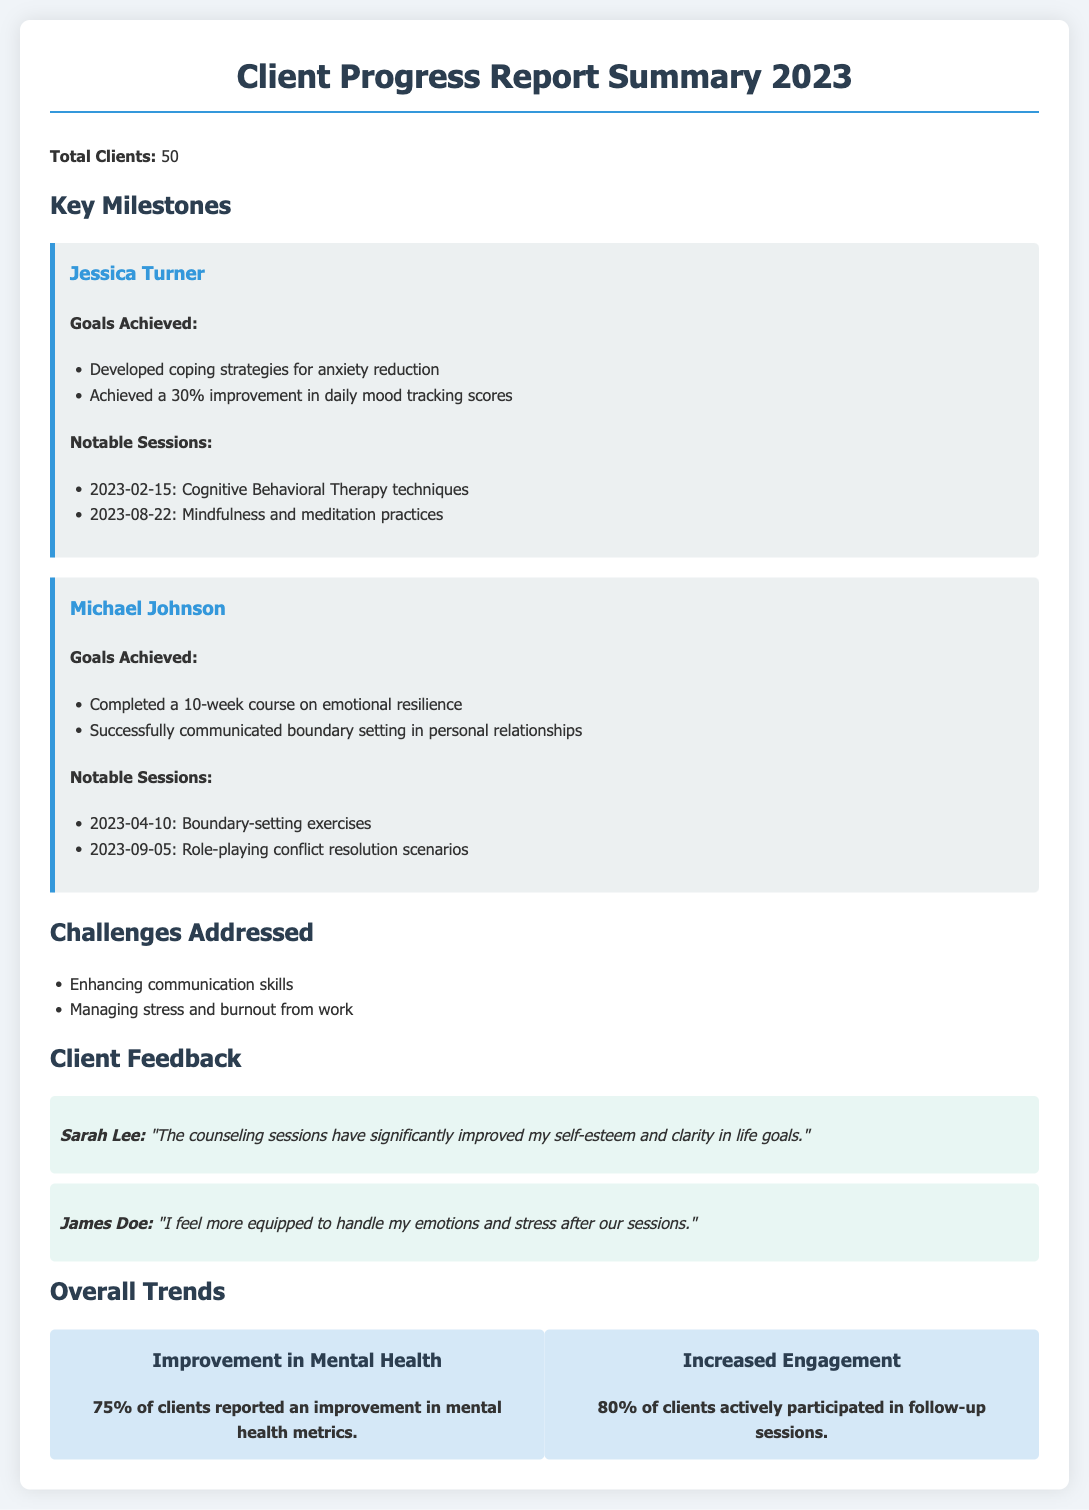What is the total number of clients? The total number of clients is stated at the beginning of the report, which is 50.
Answer: 50 What goal did Jessica Turner achieve? The document lists the goals achieved by Jessica Turner, including developing coping strategies for anxiety reduction.
Answer: Developed coping strategies for anxiety reduction When did Michael Johnson complete boundary-setting exercises? The report provides specific dates for notable sessions, including Michael Johnson's boundary-setting exercises on April 10, 2023.
Answer: 2023-04-10 What percentage of clients reported an improvement in mental health metrics? The overall trends section indicates that 75% of clients reported an improvement in mental health metrics.
Answer: 75% Which therapeutic technique did Jessica Turner practice on August 22, 2023? The report states that Jessica Turner practiced mindfulness and meditation techniques during a notable session on this date.
Answer: Mindfulness and meditation practices What challenge was addressed related to communication? The document mentions enhancing communication skills as one of the challenges addressed during the counseling sessions.
Answer: Enhancing communication skills How many clients actively participated in follow-up sessions? The document notes that 80% of clients actively participated in follow-up sessions, which is stated in the trends section.
Answer: 80% What significant feedback did Sarah Lee provide? The feedback section includes a statement from Sarah Lee about the improvement in her self-esteem and clarity in life goals.
Answer: "The counseling sessions have significantly improved my self-esteem and clarity in life goals." 